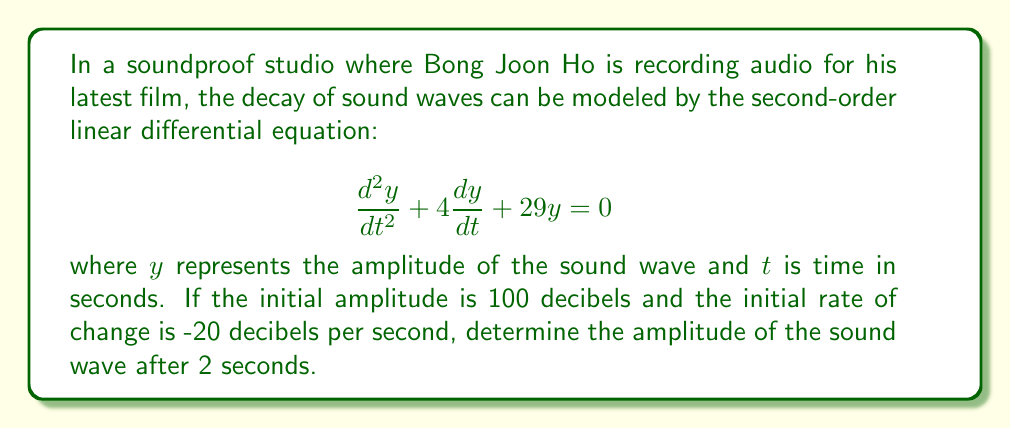What is the answer to this math problem? To solve this problem, we need to follow these steps:

1) First, we need to find the general solution to the differential equation. The characteristic equation is:

   $$r^2 + 4r + 29 = 0$$

2) Solving this quadratic equation:
   
   $$r = \frac{-4 \pm \sqrt{4^2 - 4(1)(29)}}{2(1)} = \frac{-4 \pm \sqrt{16 - 116}}{2} = \frac{-4 \pm \sqrt{-100}}{2} = -2 \pm 5i$$

3) Therefore, the general solution is:

   $$y = e^{-2t}(C_1 \cos(5t) + C_2 \sin(5t))$$

4) Now we use the initial conditions to find $C_1$ and $C_2$:
   
   At $t=0$, $y(0) = 100$ and $y'(0) = -20$

5) From $y(0) = 100$:
   
   $$100 = C_1$$

6) From $y'(0) = -20$:
   
   $$y' = -2e^{-2t}(C_1 \cos(5t) + C_2 \sin(5t)) + 5e^{-2t}(-C_1 \sin(5t) + C_2 \cos(5t))$$
   
   $$-20 = -2C_1 + 5C_2$$
   
   $$-20 = -2(100) + 5C_2$$
   
   $$180 = 5C_2$$
   
   $$C_2 = 36$$

7) Therefore, the particular solution is:

   $$y = e^{-2t}(100 \cos(5t) + 36 \sin(5t))$$

8) To find the amplitude after 2 seconds, we substitute $t=2$:

   $$y(2) = e^{-4}(100 \cos(10) + 36 \sin(10))$$

9) Calculating this value:

   $$y(2) \approx 0.0183 \cdot (100 \cdot (-0.8391) + 36 \cdot (-0.5440)) \approx -1.84$$

10) Since amplitude is always positive, we take the absolute value:

    $$|y(2)| \approx 1.84$$
Answer: The amplitude of the sound wave after 2 seconds is approximately 1.84 decibels. 